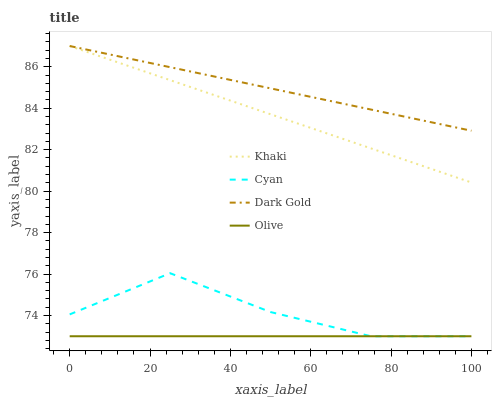Does Cyan have the minimum area under the curve?
Answer yes or no. No. Does Cyan have the maximum area under the curve?
Answer yes or no. No. Is Khaki the smoothest?
Answer yes or no. No. Is Khaki the roughest?
Answer yes or no. No. Does Khaki have the lowest value?
Answer yes or no. No. Does Cyan have the highest value?
Answer yes or no. No. Is Olive less than Dark Gold?
Answer yes or no. Yes. Is Dark Gold greater than Cyan?
Answer yes or no. Yes. Does Olive intersect Dark Gold?
Answer yes or no. No. 